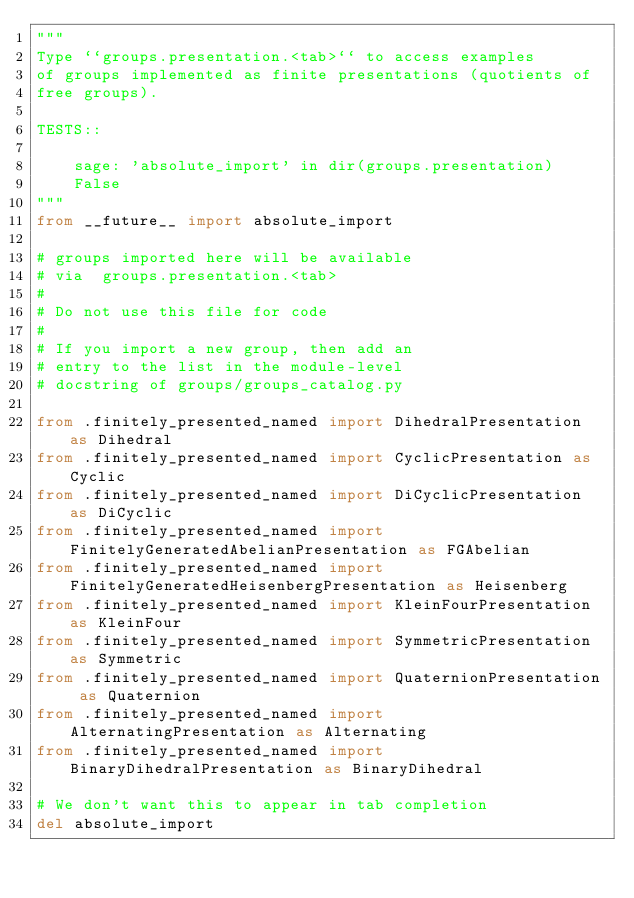<code> <loc_0><loc_0><loc_500><loc_500><_Python_>"""
Type ``groups.presentation.<tab>`` to access examples
of groups implemented as finite presentations (quotients of
free groups).

TESTS::

    sage: 'absolute_import' in dir(groups.presentation)
    False
"""
from __future__ import absolute_import

# groups imported here will be available
# via  groups.presentation.<tab>
#
# Do not use this file for code
#
# If you import a new group, then add an
# entry to the list in the module-level
# docstring of groups/groups_catalog.py

from .finitely_presented_named import DihedralPresentation as Dihedral
from .finitely_presented_named import CyclicPresentation as Cyclic
from .finitely_presented_named import DiCyclicPresentation as DiCyclic
from .finitely_presented_named import FinitelyGeneratedAbelianPresentation as FGAbelian
from .finitely_presented_named import FinitelyGeneratedHeisenbergPresentation as Heisenberg
from .finitely_presented_named import KleinFourPresentation as KleinFour
from .finitely_presented_named import SymmetricPresentation as Symmetric
from .finitely_presented_named import QuaternionPresentation as Quaternion
from .finitely_presented_named import AlternatingPresentation as Alternating
from .finitely_presented_named import BinaryDihedralPresentation as BinaryDihedral

# We don't want this to appear in tab completion
del absolute_import
</code> 